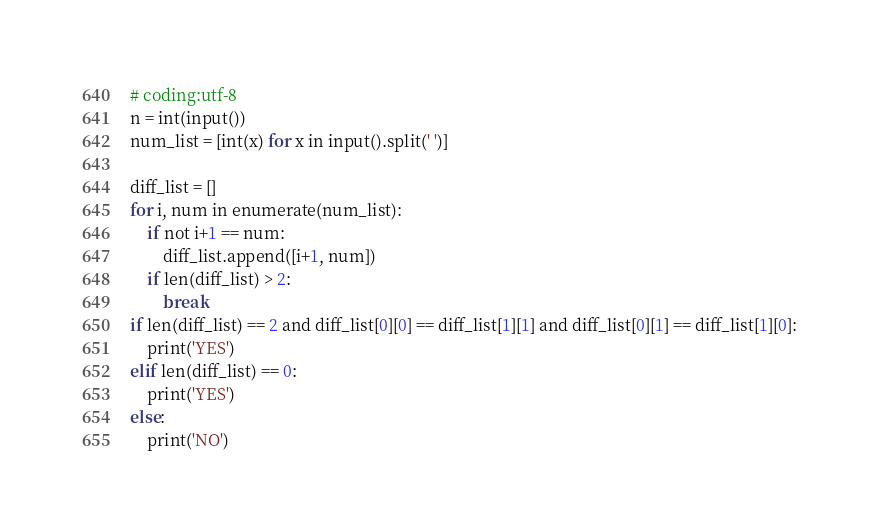Convert code to text. <code><loc_0><loc_0><loc_500><loc_500><_Python_># coding:utf-8
n = int(input())
num_list = [int(x) for x in input().split(' ')]

diff_list = []
for i, num in enumerate(num_list):
    if not i+1 == num:
        diff_list.append([i+1, num])
    if len(diff_list) > 2:
        break
if len(diff_list) == 2 and diff_list[0][0] == diff_list[1][1] and diff_list[0][1] == diff_list[1][0]:
    print('YES')
elif len(diff_list) == 0:
    print('YES')
else:
    print('NO')</code> 